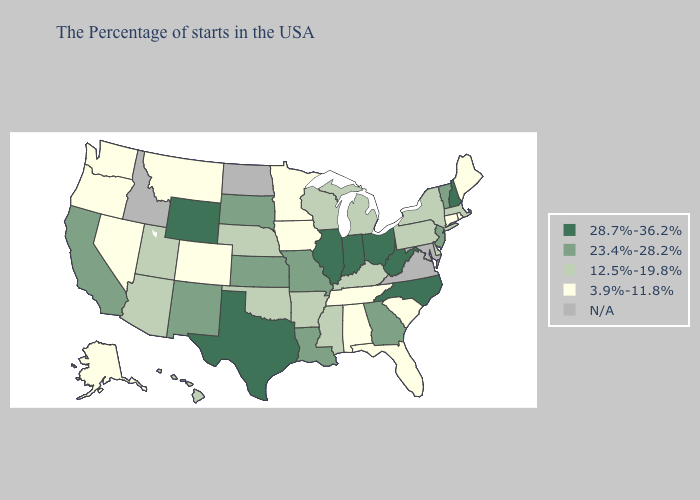What is the lowest value in the USA?
Be succinct. 3.9%-11.8%. Name the states that have a value in the range 28.7%-36.2%?
Short answer required. New Hampshire, North Carolina, West Virginia, Ohio, Indiana, Illinois, Texas, Wyoming. What is the value of Arizona?
Short answer required. 12.5%-19.8%. Does California have the lowest value in the USA?
Quick response, please. No. What is the highest value in the South ?
Short answer required. 28.7%-36.2%. Among the states that border Wyoming , does South Dakota have the highest value?
Quick response, please. Yes. Among the states that border North Dakota , does Minnesota have the lowest value?
Write a very short answer. Yes. Does Indiana have the highest value in the MidWest?
Write a very short answer. Yes. How many symbols are there in the legend?
Write a very short answer. 5. Does South Dakota have the lowest value in the MidWest?
Concise answer only. No. Among the states that border Ohio , which have the highest value?
Keep it brief. West Virginia, Indiana. What is the value of Alaska?
Write a very short answer. 3.9%-11.8%. Among the states that border Iowa , does South Dakota have the highest value?
Short answer required. No. Which states have the highest value in the USA?
Answer briefly. New Hampshire, North Carolina, West Virginia, Ohio, Indiana, Illinois, Texas, Wyoming. 